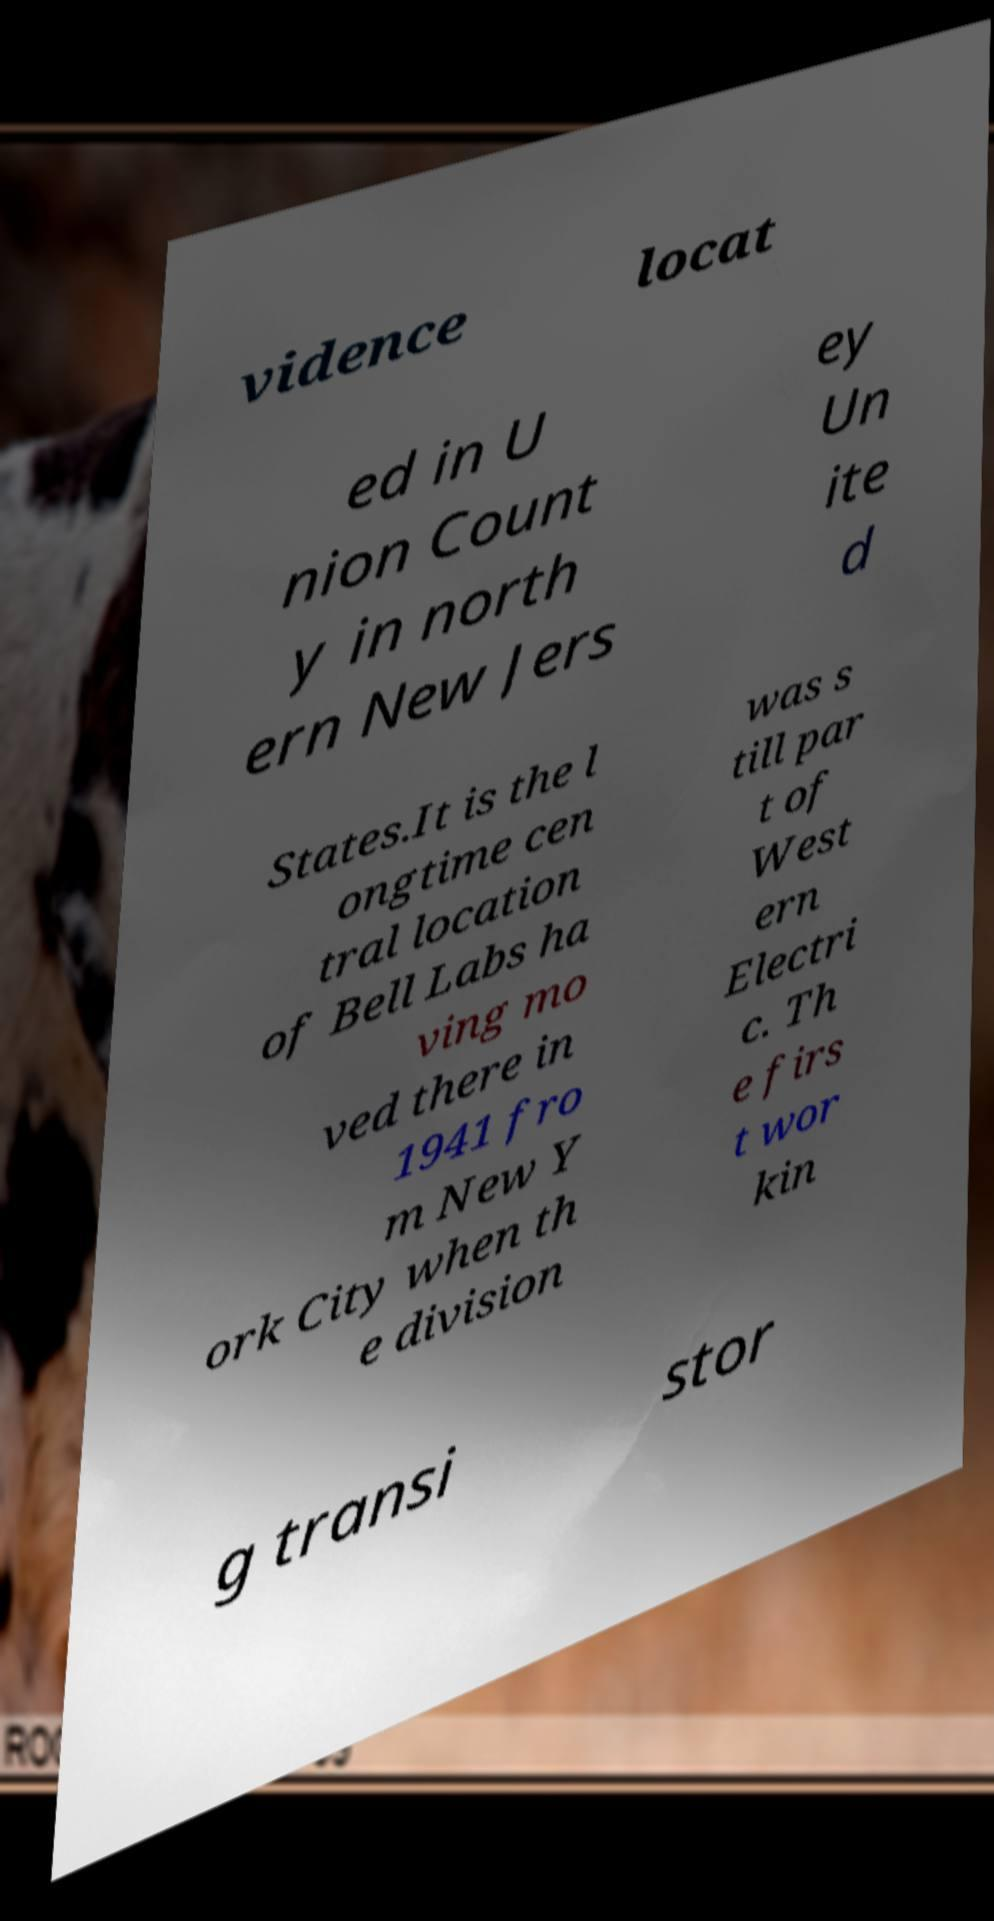Please read and relay the text visible in this image. What does it say? vidence locat ed in U nion Count y in north ern New Jers ey Un ite d States.It is the l ongtime cen tral location of Bell Labs ha ving mo ved there in 1941 fro m New Y ork City when th e division was s till par t of West ern Electri c. Th e firs t wor kin g transi stor 